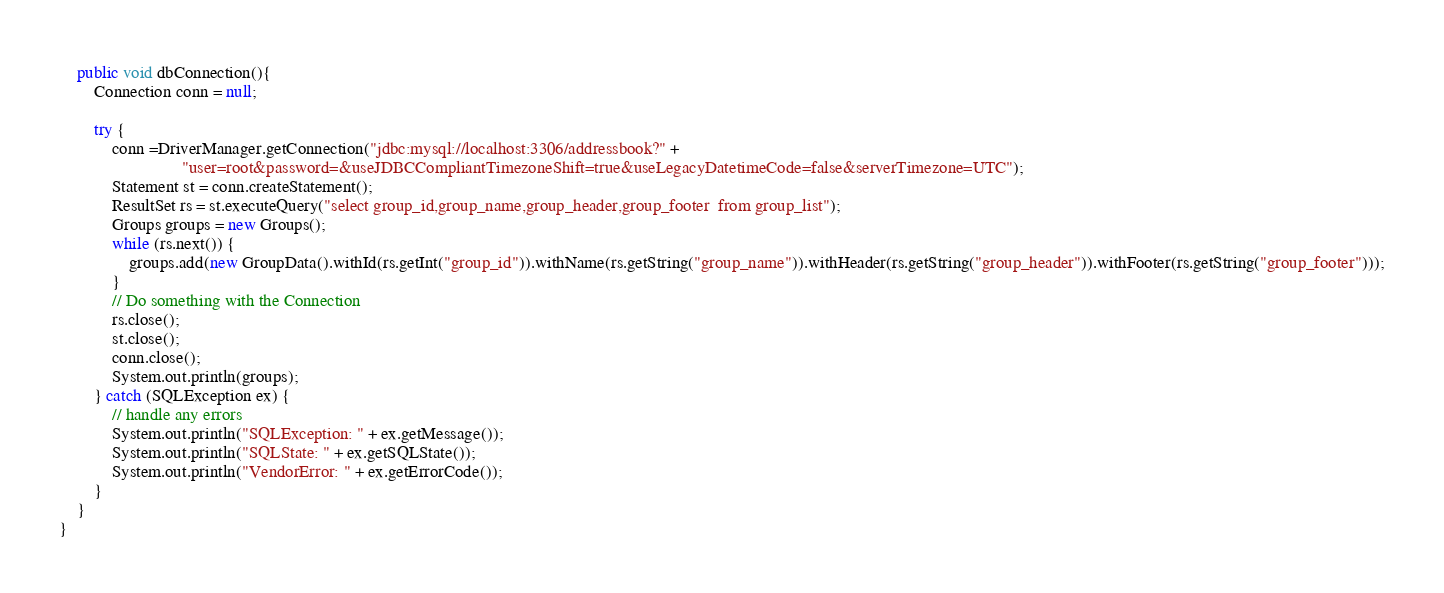<code> <loc_0><loc_0><loc_500><loc_500><_Java_>    public void dbConnection(){
        Connection conn = null;

        try {
            conn =DriverManager.getConnection("jdbc:mysql://localhost:3306/addressbook?" +
                            "user=root&password=&useJDBCCompliantTimezoneShift=true&useLegacyDatetimeCode=false&serverTimezone=UTC");
            Statement st = conn.createStatement();
            ResultSet rs = st.executeQuery("select group_id,group_name,group_header,group_footer  from group_list");
            Groups groups = new Groups();
            while (rs.next()) {
                groups.add(new GroupData().withId(rs.getInt("group_id")).withName(rs.getString("group_name")).withHeader(rs.getString("group_header")).withFooter(rs.getString("group_footer")));
            }
            // Do something with the Connection
            rs.close();
            st.close();
            conn.close();
            System.out.println(groups);
        } catch (SQLException ex) {
            // handle any errors
            System.out.println("SQLException: " + ex.getMessage());
            System.out.println("SQLState: " + ex.getSQLState());
            System.out.println("VendorError: " + ex.getErrorCode());
        }
    }
}
</code> 